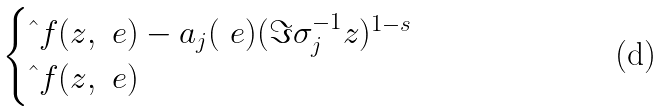Convert formula to latex. <formula><loc_0><loc_0><loc_500><loc_500>\begin{cases} \hat { \ } f ( z , \ e ) - a _ { j } ( \ e ) ( \Im { \sigma _ { j } ^ { - 1 } z } ) ^ { 1 - s } \\ \hat { \ } f ( z , \ e ) \end{cases}</formula> 